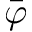Convert formula to latex. <formula><loc_0><loc_0><loc_500><loc_500>\bar { \varphi }</formula> 